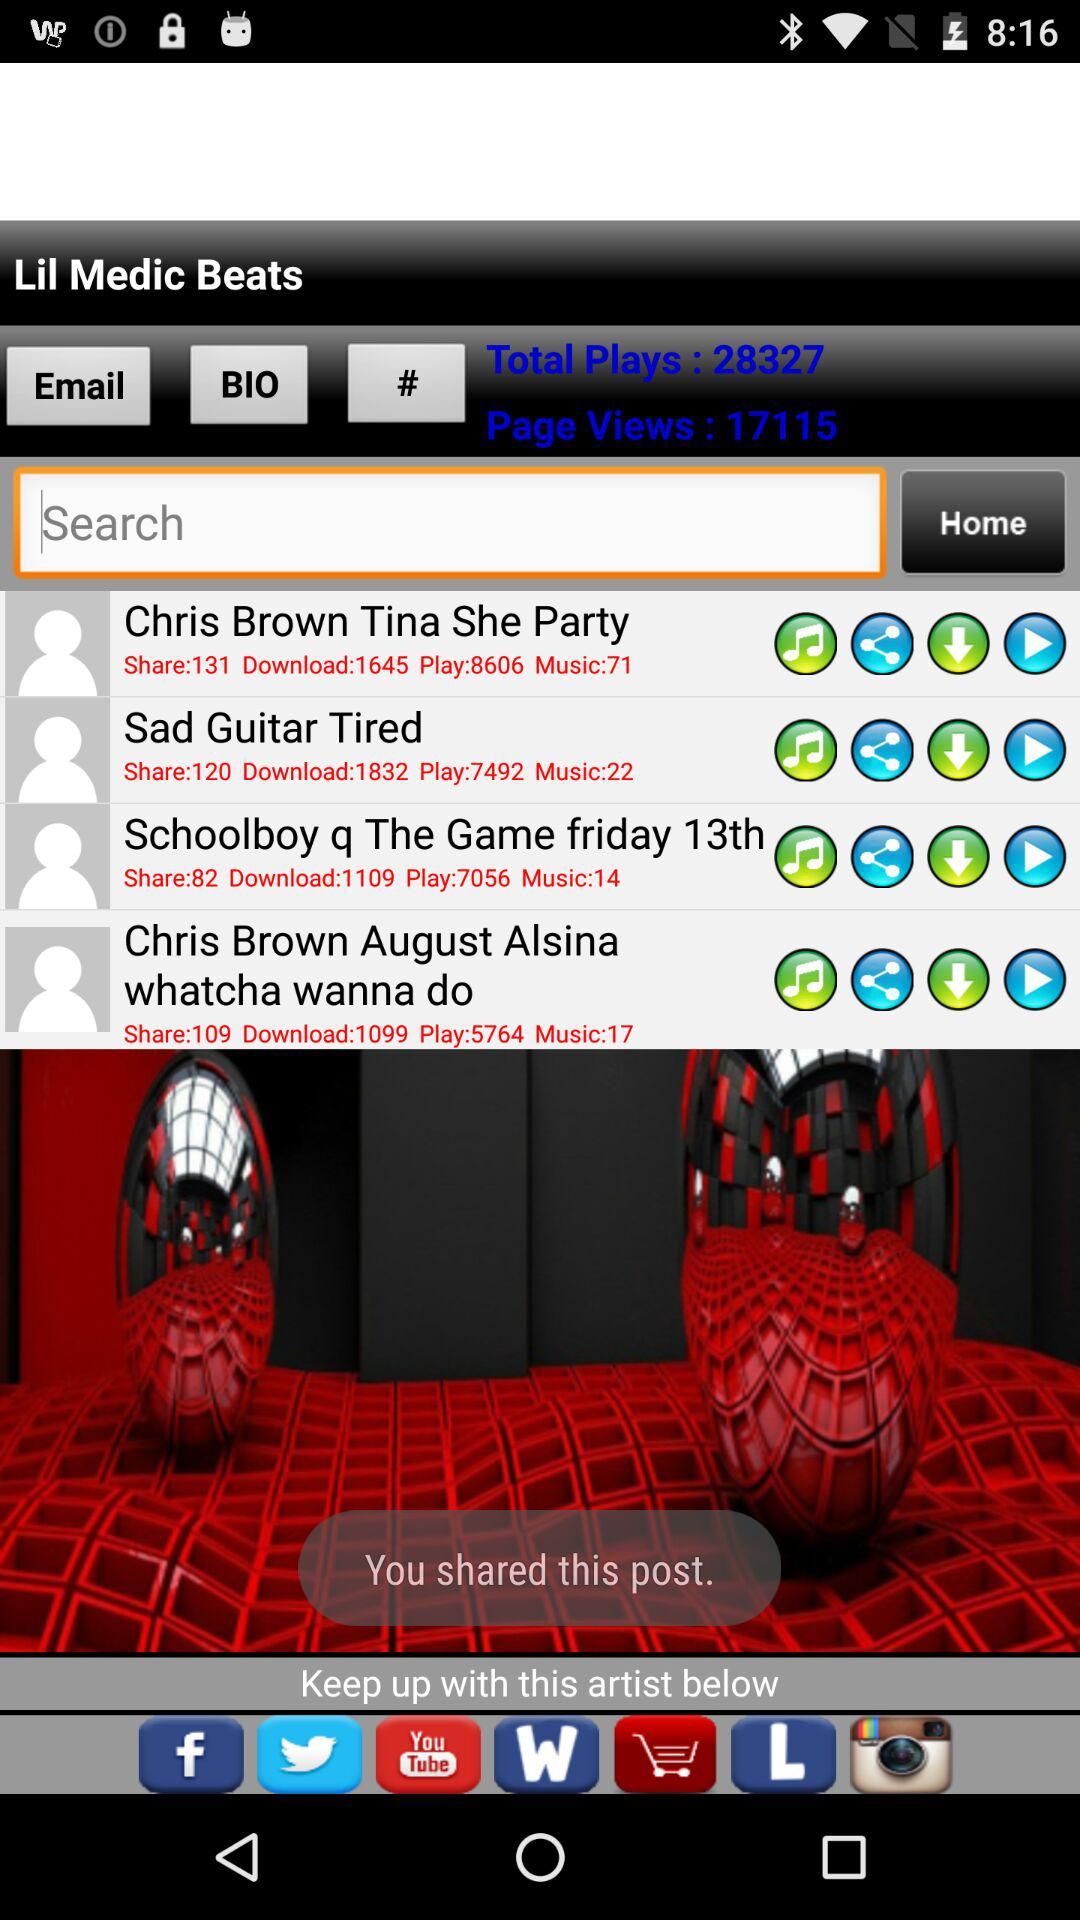What's the total number of shares of "Chris Brown Tina She Party"? The total number of shares is 131. 